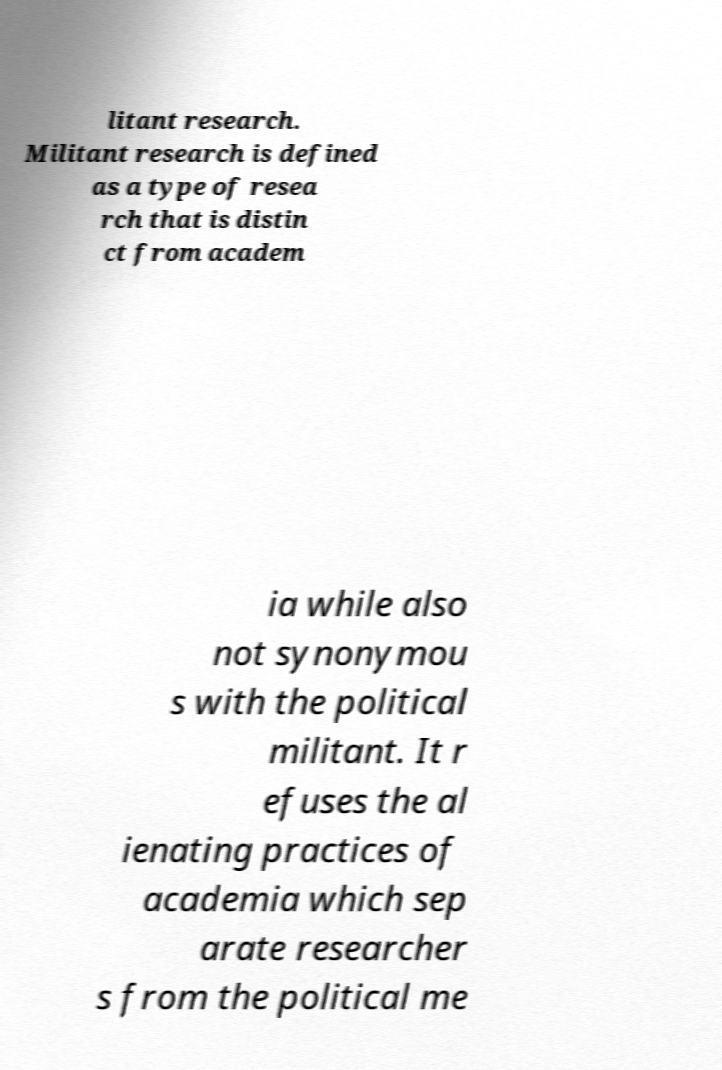Could you extract and type out the text from this image? litant research. Militant research is defined as a type of resea rch that is distin ct from academ ia while also not synonymou s with the political militant. It r efuses the al ienating practices of academia which sep arate researcher s from the political me 